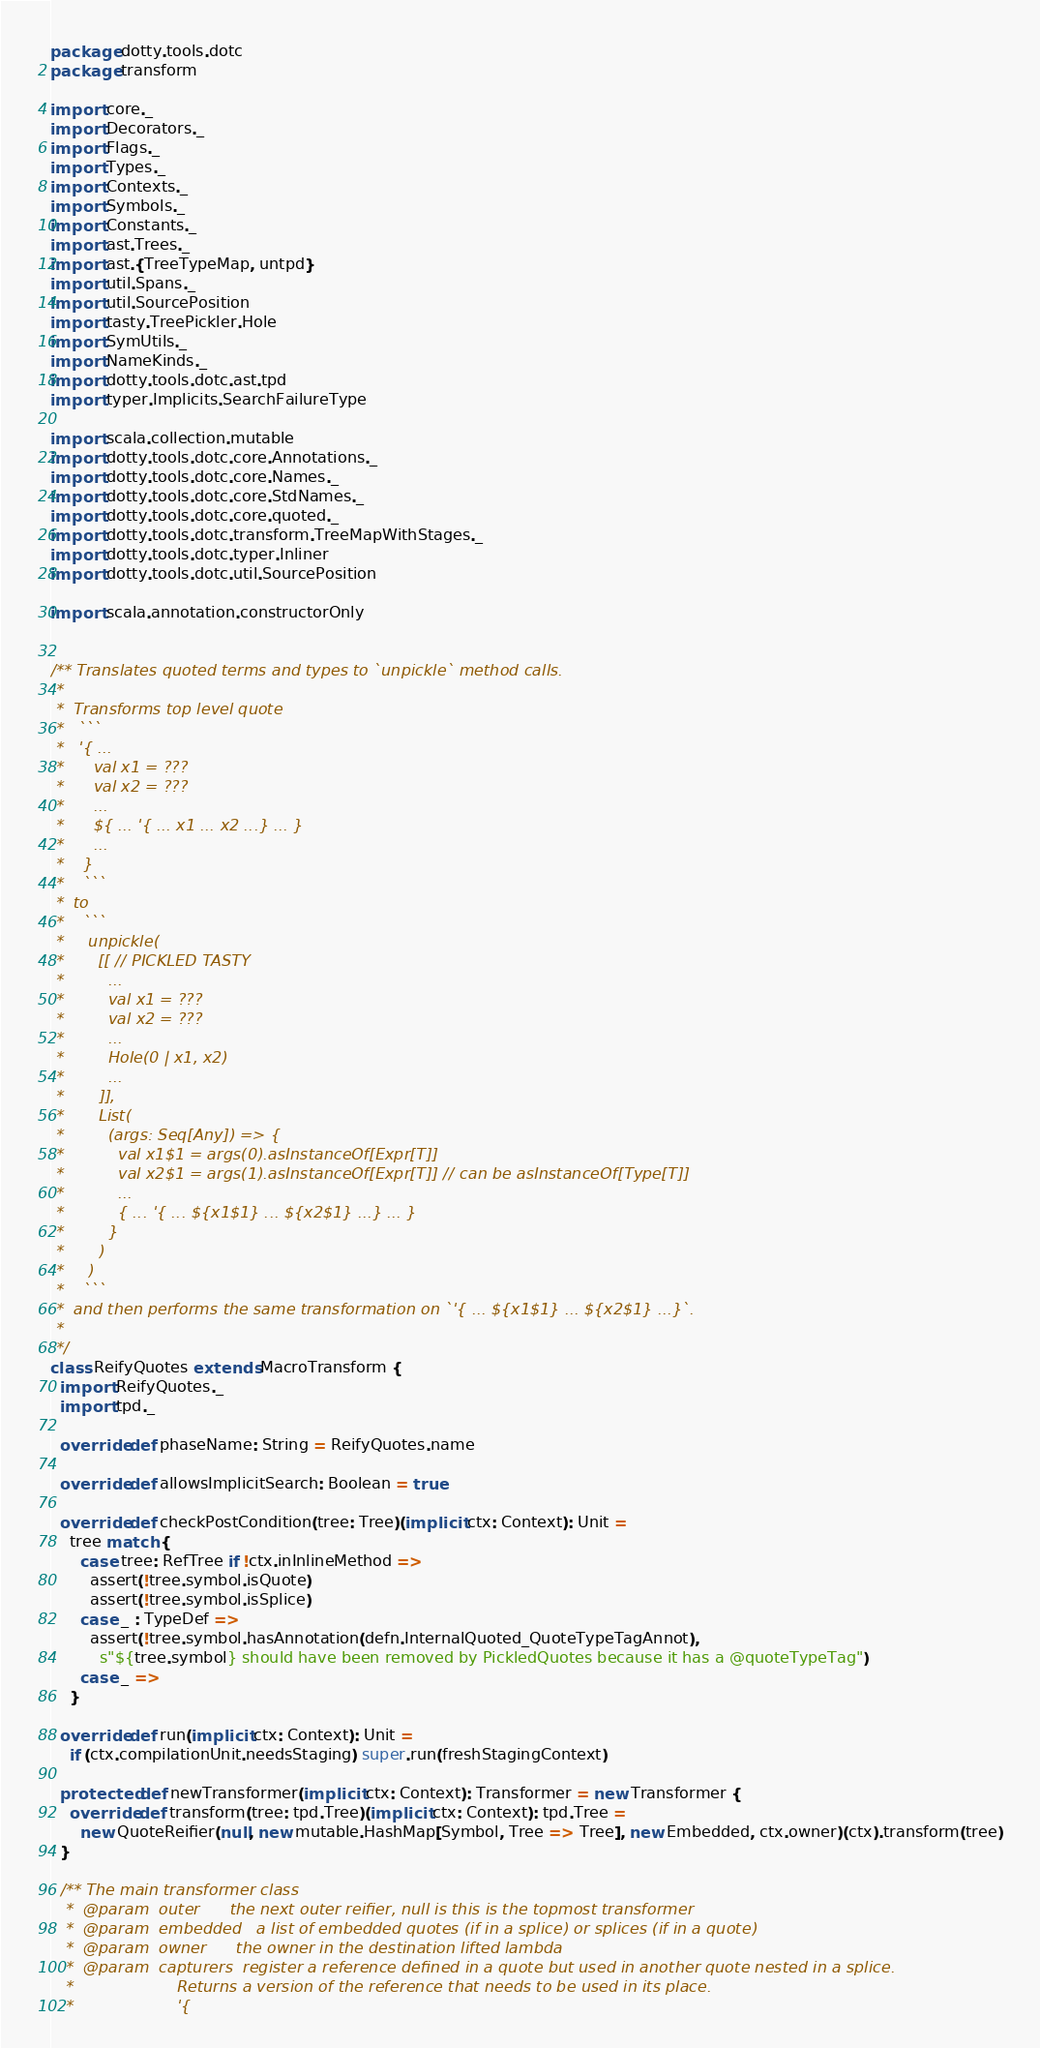<code> <loc_0><loc_0><loc_500><loc_500><_Scala_>package dotty.tools.dotc
package transform

import core._
import Decorators._
import Flags._
import Types._
import Contexts._
import Symbols._
import Constants._
import ast.Trees._
import ast.{TreeTypeMap, untpd}
import util.Spans._
import util.SourcePosition
import tasty.TreePickler.Hole
import SymUtils._
import NameKinds._
import dotty.tools.dotc.ast.tpd
import typer.Implicits.SearchFailureType

import scala.collection.mutable
import dotty.tools.dotc.core.Annotations._
import dotty.tools.dotc.core.Names._
import dotty.tools.dotc.core.StdNames._
import dotty.tools.dotc.core.quoted._
import dotty.tools.dotc.transform.TreeMapWithStages._
import dotty.tools.dotc.typer.Inliner
import dotty.tools.dotc.util.SourcePosition

import scala.annotation.constructorOnly


/** Translates quoted terms and types to `unpickle` method calls.
 *
 *  Transforms top level quote
 *   ```
 *   '{ ...
 *      val x1 = ???
 *      val x2 = ???
 *      ...
 *      ${ ... '{ ... x1 ... x2 ...} ... }
 *      ...
 *    }
 *    ```
 *  to
 *    ```
 *     unpickle(
 *       [[ // PICKLED TASTY
 *         ...
 *         val x1 = ???
 *         val x2 = ???
 *         ...
 *         Hole(0 | x1, x2)
 *         ...
 *       ]],
 *       List(
 *         (args: Seq[Any]) => {
 *           val x1$1 = args(0).asInstanceOf[Expr[T]]
 *           val x2$1 = args(1).asInstanceOf[Expr[T]] // can be asInstanceOf[Type[T]]
 *           ...
 *           { ... '{ ... ${x1$1} ... ${x2$1} ...} ... }
 *         }
 *       )
 *     )
 *    ```
 *  and then performs the same transformation on `'{ ... ${x1$1} ... ${x2$1} ...}`.
 *
 */
class ReifyQuotes extends MacroTransform {
  import ReifyQuotes._
  import tpd._

  override def phaseName: String = ReifyQuotes.name

  override def allowsImplicitSearch: Boolean = true

  override def checkPostCondition(tree: Tree)(implicit ctx: Context): Unit =
    tree match {
      case tree: RefTree if !ctx.inInlineMethod =>
        assert(!tree.symbol.isQuote)
        assert(!tree.symbol.isSplice)
      case _ : TypeDef =>
        assert(!tree.symbol.hasAnnotation(defn.InternalQuoted_QuoteTypeTagAnnot),
          s"${tree.symbol} should have been removed by PickledQuotes because it has a @quoteTypeTag")
      case _ =>
    }

  override def run(implicit ctx: Context): Unit =
    if (ctx.compilationUnit.needsStaging) super.run(freshStagingContext)

  protected def newTransformer(implicit ctx: Context): Transformer = new Transformer {
    override def transform(tree: tpd.Tree)(implicit ctx: Context): tpd.Tree =
      new QuoteReifier(null, new mutable.HashMap[Symbol, Tree => Tree], new Embedded, ctx.owner)(ctx).transform(tree)
  }

  /** The main transformer class
   *  @param  outer      the next outer reifier, null is this is the topmost transformer
   *  @param  embedded   a list of embedded quotes (if in a splice) or splices (if in a quote)
   *  @param  owner      the owner in the destination lifted lambda
   *  @param  capturers  register a reference defined in a quote but used in another quote nested in a splice.
   *                     Returns a version of the reference that needs to be used in its place.
   *                     '{</code> 